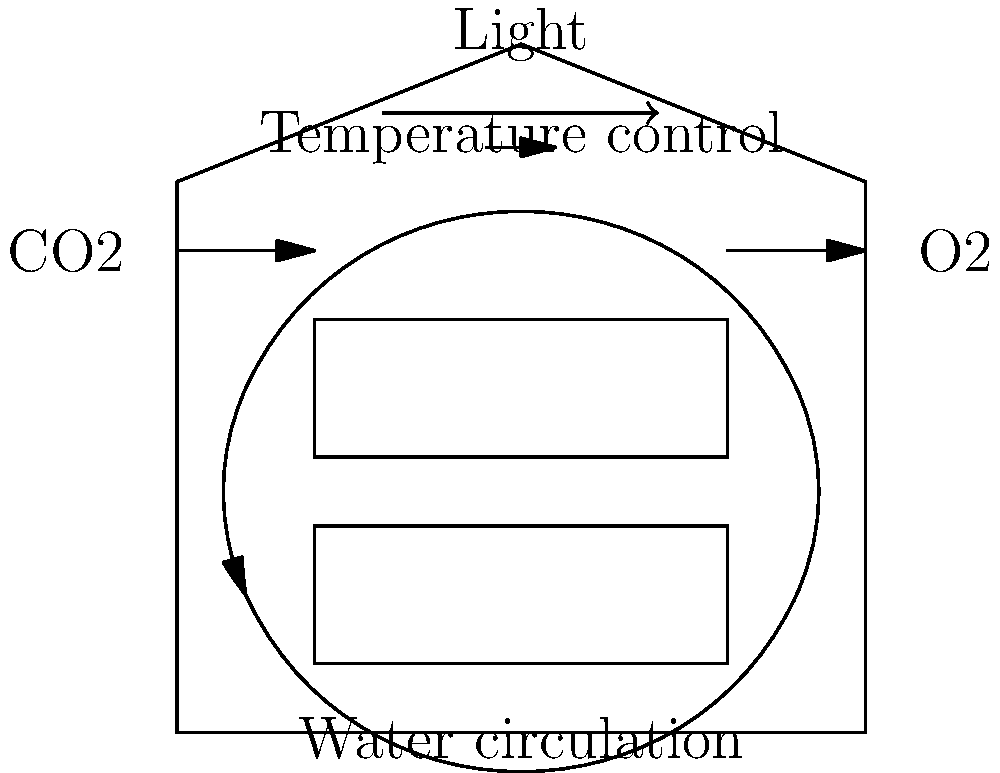As a biologist specializing in algae, you've been consulted on the design of a greenhouse for optimal algae growth. The cross-sectional diagram shows a proposed structure. Which key feature, crucial for maintaining ideal growth conditions, is missing from this design that would significantly impact the algae's photosynthetic efficiency and overall productivity? Let's analyze the diagram and consider the essential elements for algae growth:

1. Light source: Present, crucial for photosynthesis.
2. Water circulation: Present, ensures nutrient distribution.
3. CO2 input: Present, necessary for carbon fixation in photosynthesis.
4. O2 output: Present, removes excess oxygen produced during photosynthesis.
5. Temperature control: Present, maintains optimal growth conditions.
6. Growth tanks: Present, provide space for algae cultivation.

However, one critical element is missing:

7. pH control system: Absent from the diagram.

The pH level is crucial for algae growth for several reasons:

a) Enzyme activity: Algal enzymes function optimally within specific pH ranges.
b) Nutrient availability: pH affects the solubility and uptake of essential nutrients.
c) Carbon dioxide utilization: The form of inorganic carbon (CO2, bicarbonate, or carbonate) available to algae depends on pH.
d) Species selection: Different algae species thrive in different pH ranges.
e) Contamination control: Maintaining the right pH can help prevent the growth of unwanted microorganisms.

In a high-productivity algae cultivation system, the pH can fluctuate rapidly due to CO2 consumption during photosynthesis. Without a pH control system, the efficiency of carbon uptake and overall productivity would be significantly impacted.

Therefore, the addition of a pH monitoring and adjustment system is crucial for maintaining optimal growth conditions and ensuring maximum algae productivity in this greenhouse design.
Answer: pH control system 